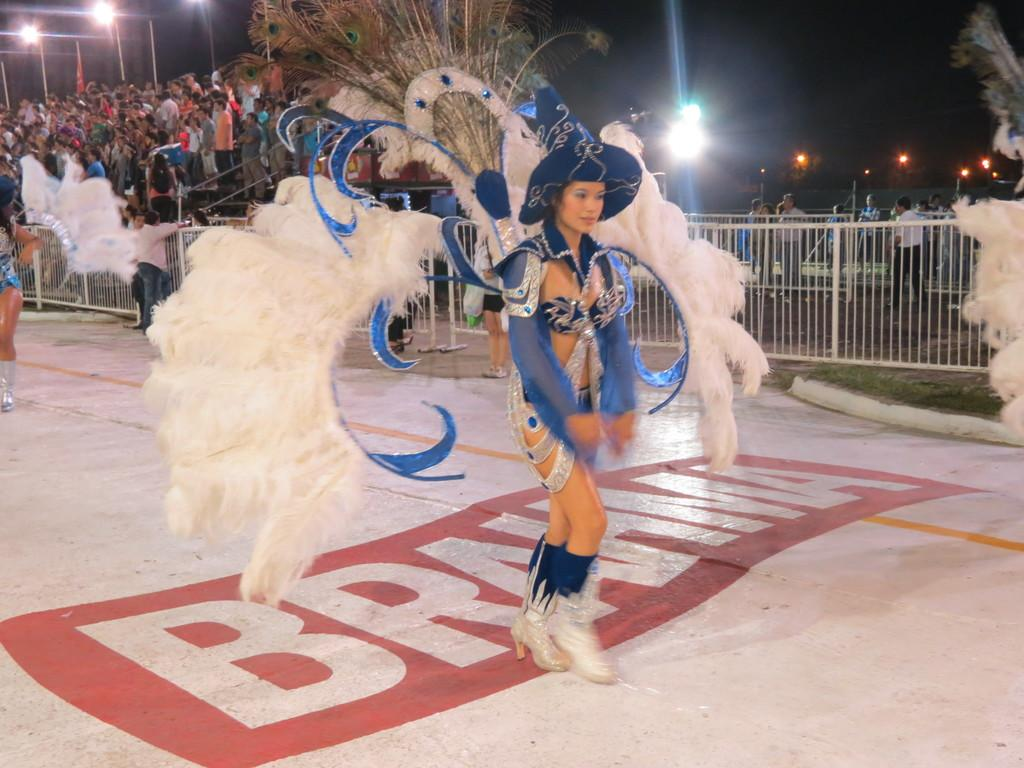How many people are in the image? There are people in the image, but the exact number is not specified. What are some people wearing in the image? Some people are wearing different costumes in the image. What can be seen in the background of the image? In the background of the image, there are grills, stairs, poles, and lights. How would you describe the lighting in the background of the image? The background view is dark, indicating that the lighting is dim or low. What type of brass instrument is being played by the dad in the image? There is no dad or brass instrument present in the image. How many ducks are visible in the image? There are no ducks present in the image. 